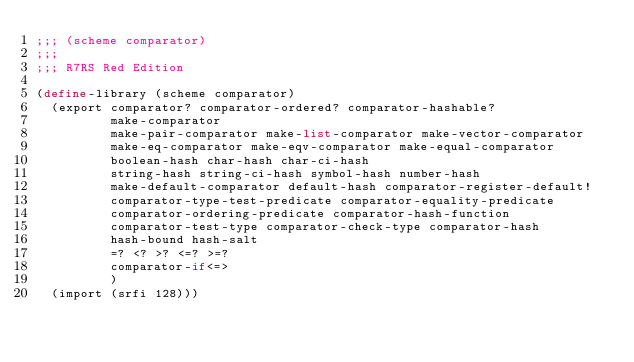Convert code to text. <code><loc_0><loc_0><loc_500><loc_500><_Scheme_>;;; (scheme comparator)
;;;
;;; R7RS Red Edition

(define-library (scheme comparator)
  (export comparator? comparator-ordered? comparator-hashable?
          make-comparator
          make-pair-comparator make-list-comparator make-vector-comparator
          make-eq-comparator make-eqv-comparator make-equal-comparator
          boolean-hash char-hash char-ci-hash
          string-hash string-ci-hash symbol-hash number-hash
          make-default-comparator default-hash comparator-register-default!
          comparator-type-test-predicate comparator-equality-predicate
          comparator-ordering-predicate comparator-hash-function
          comparator-test-type comparator-check-type comparator-hash
          hash-bound hash-salt
          =? <? >? <=? >=?
          comparator-if<=>
          )
  (import (srfi 128)))
</code> 